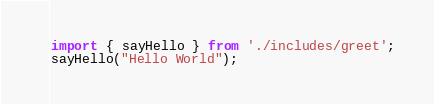<code> <loc_0><loc_0><loc_500><loc_500><_TypeScript_>import { sayHello } from './includes/greet';
sayHello("Hello World");
</code> 